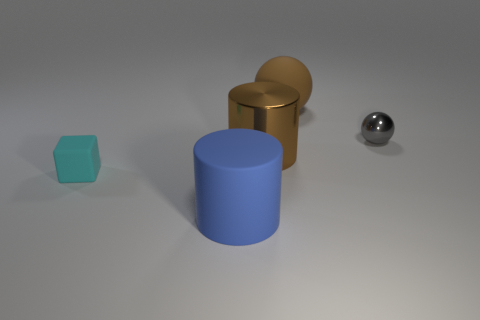How many gray spheres are on the left side of the matte object right of the big blue rubber object?
Ensure brevity in your answer.  0. Are there more brown shiny cylinders that are behind the large brown ball than big metallic blocks?
Keep it short and to the point. No. What size is the rubber object that is behind the blue matte thing and on the right side of the cyan matte cube?
Your answer should be very brief. Large. What shape is the object that is both on the left side of the brown sphere and behind the cyan object?
Make the answer very short. Cylinder. Is there a brown sphere that is on the right side of the shiny thing on the left side of the big object behind the small gray thing?
Keep it short and to the point. Yes. What number of things are big brown things that are left of the brown sphere or big objects that are on the left side of the metal cylinder?
Make the answer very short. 2. Is the big brown thing left of the big rubber sphere made of the same material as the small cyan object?
Your response must be concise. No. What is the large object that is behind the big blue object and in front of the small shiny thing made of?
Make the answer very short. Metal. What color is the tiny thing behind the matte thing that is to the left of the blue cylinder?
Offer a terse response. Gray. What material is the other large object that is the same shape as the gray thing?
Your answer should be compact. Rubber. 